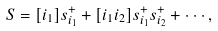<formula> <loc_0><loc_0><loc_500><loc_500>S = [ i _ { 1 } ] s ^ { + } _ { i _ { 1 } } + [ i _ { 1 } i _ { 2 } ] s ^ { + } _ { i _ { 1 } } s ^ { + } _ { i _ { 2 } } + \cdot \cdot \cdot \, ,</formula> 